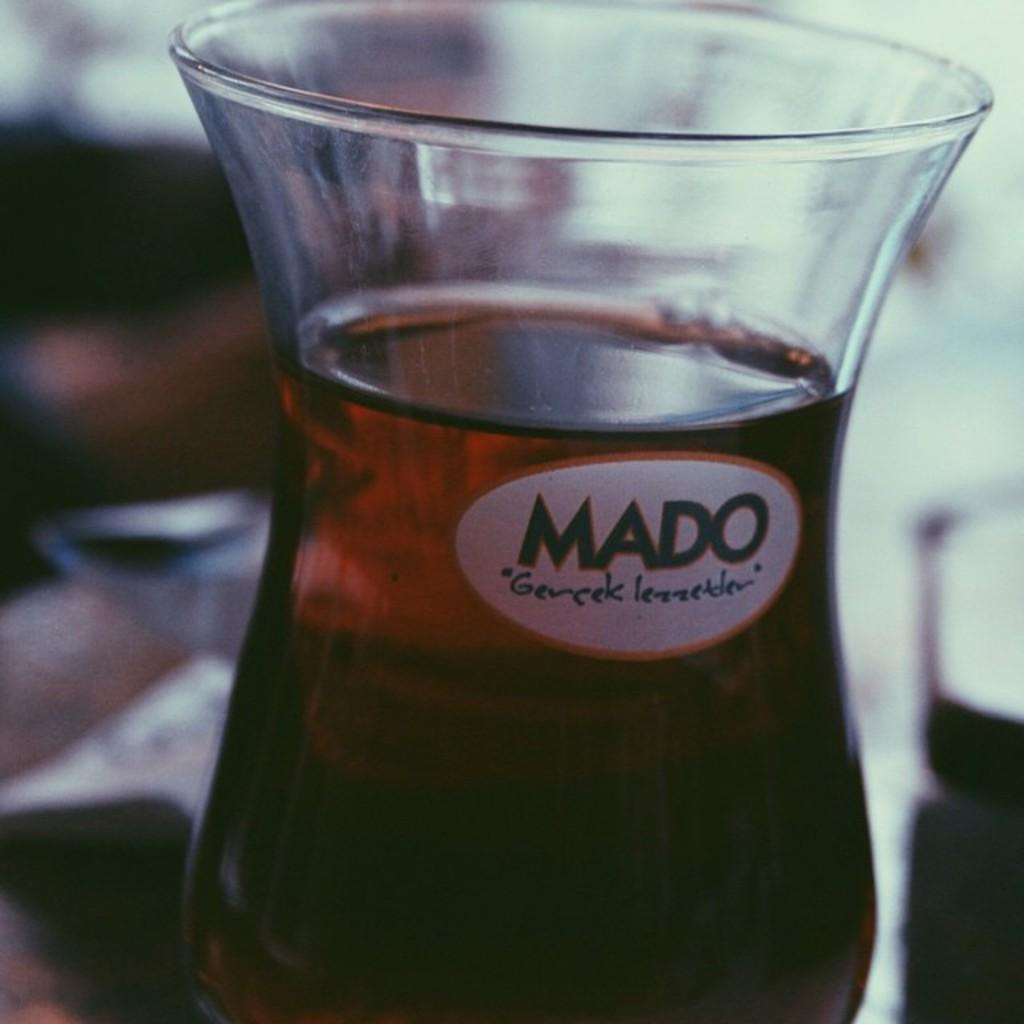<image>
Provide a brief description of the given image. A glass of amber color Mado Gevcek lezzetlev on a table. 